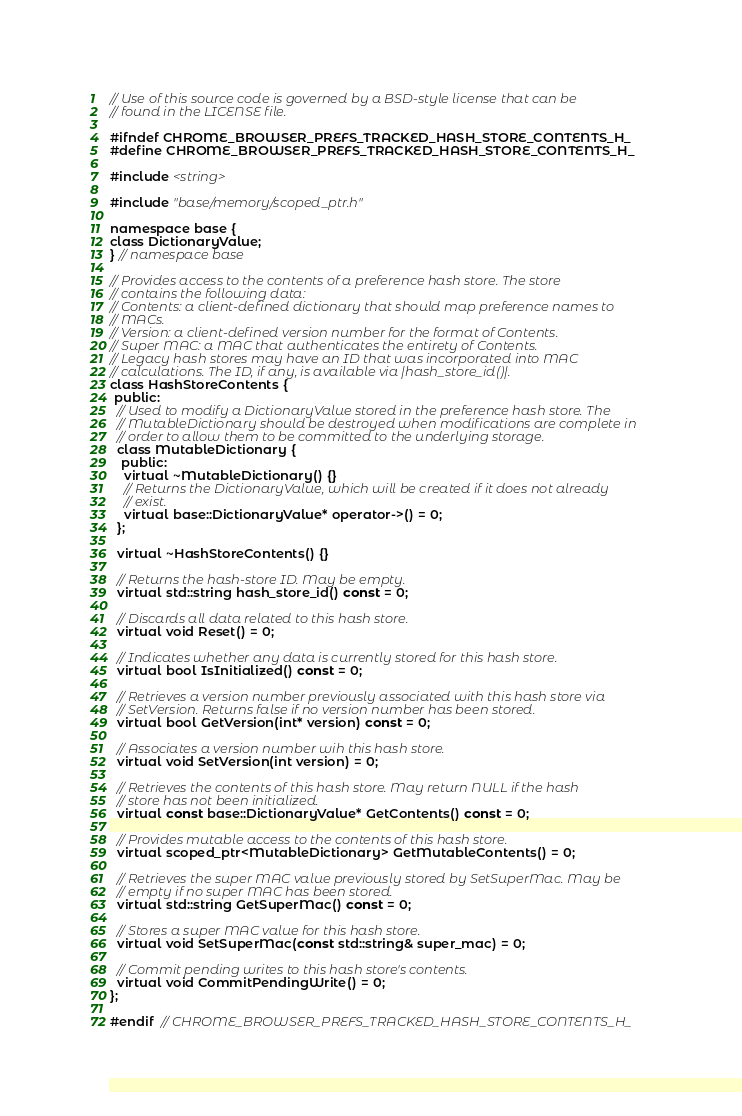<code> <loc_0><loc_0><loc_500><loc_500><_C_>// Use of this source code is governed by a BSD-style license that can be
// found in the LICENSE file.

#ifndef CHROME_BROWSER_PREFS_TRACKED_HASH_STORE_CONTENTS_H_
#define CHROME_BROWSER_PREFS_TRACKED_HASH_STORE_CONTENTS_H_

#include <string>

#include "base/memory/scoped_ptr.h"

namespace base {
class DictionaryValue;
} // namespace base

// Provides access to the contents of a preference hash store. The store
// contains the following data:
// Contents: a client-defined dictionary that should map preference names to
// MACs.
// Version: a client-defined version number for the format of Contents.
// Super MAC: a MAC that authenticates the entirety of Contents.
// Legacy hash stores may have an ID that was incorporated into MAC
// calculations. The ID, if any, is available via |hash_store_id()|.
class HashStoreContents {
 public:
  // Used to modify a DictionaryValue stored in the preference hash store. The
  // MutableDictionary should be destroyed when modifications are complete in
  // order to allow them to be committed to the underlying storage.
  class MutableDictionary {
   public:
    virtual ~MutableDictionary() {}
    // Returns the DictionaryValue, which will be created if it does not already
    // exist.
    virtual base::DictionaryValue* operator->() = 0;
  };

  virtual ~HashStoreContents() {}

  // Returns the hash-store ID. May be empty.
  virtual std::string hash_store_id() const = 0;

  // Discards all data related to this hash store.
  virtual void Reset() = 0;

  // Indicates whether any data is currently stored for this hash store.
  virtual bool IsInitialized() const = 0;

  // Retrieves a version number previously associated with this hash store via
  // SetVersion. Returns false if no version number has been stored.
  virtual bool GetVersion(int* version) const = 0;

  // Associates a version number wih this hash store.
  virtual void SetVersion(int version) = 0;

  // Retrieves the contents of this hash store. May return NULL if the hash
  // store has not been initialized.
  virtual const base::DictionaryValue* GetContents() const = 0;

  // Provides mutable access to the contents of this hash store.
  virtual scoped_ptr<MutableDictionary> GetMutableContents() = 0;

  // Retrieves the super MAC value previously stored by SetSuperMac. May be
  // empty if no super MAC has been stored.
  virtual std::string GetSuperMac() const = 0;

  // Stores a super MAC value for this hash store.
  virtual void SetSuperMac(const std::string& super_mac) = 0;

  // Commit pending writes to this hash store's contents.
  virtual void CommitPendingWrite() = 0;
};

#endif  // CHROME_BROWSER_PREFS_TRACKED_HASH_STORE_CONTENTS_H_
</code> 